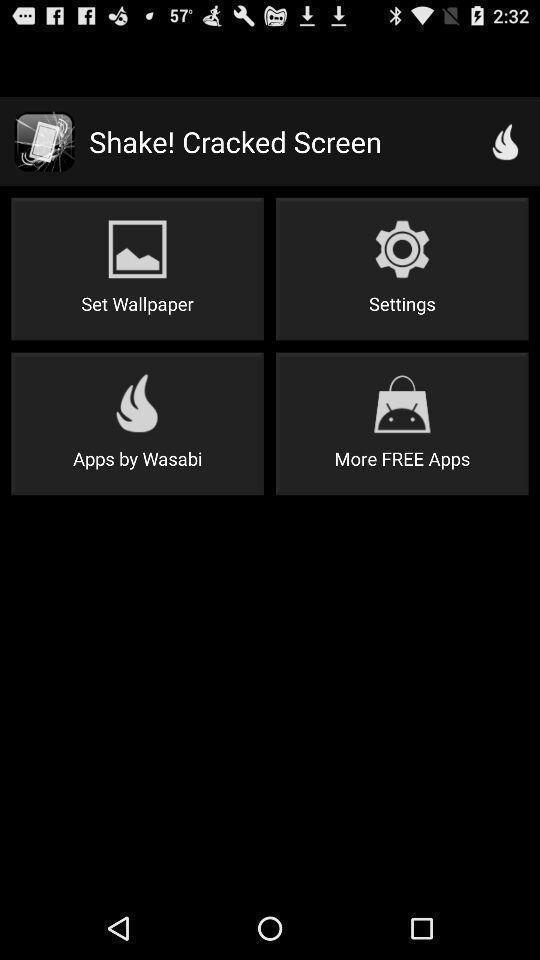Explain what's happening in this screen capture. Page with wallpaper and other options. 